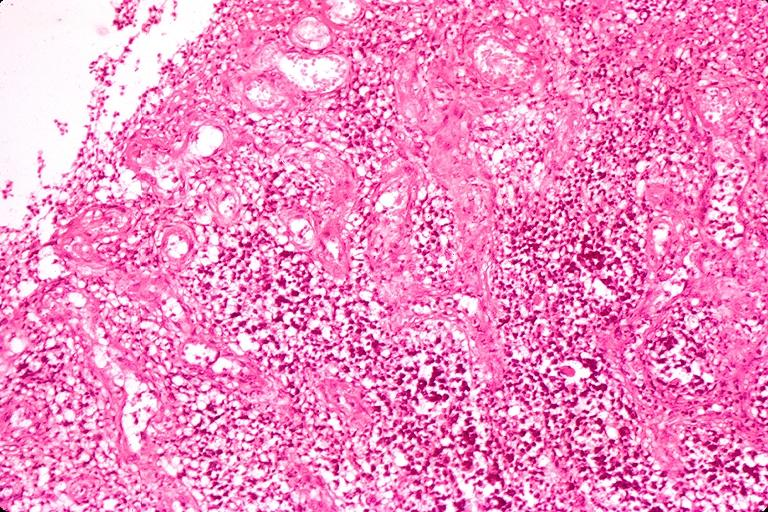what does this image show?
Answer the question using a single word or phrase. Chronic hyperplasitic pulpitis 